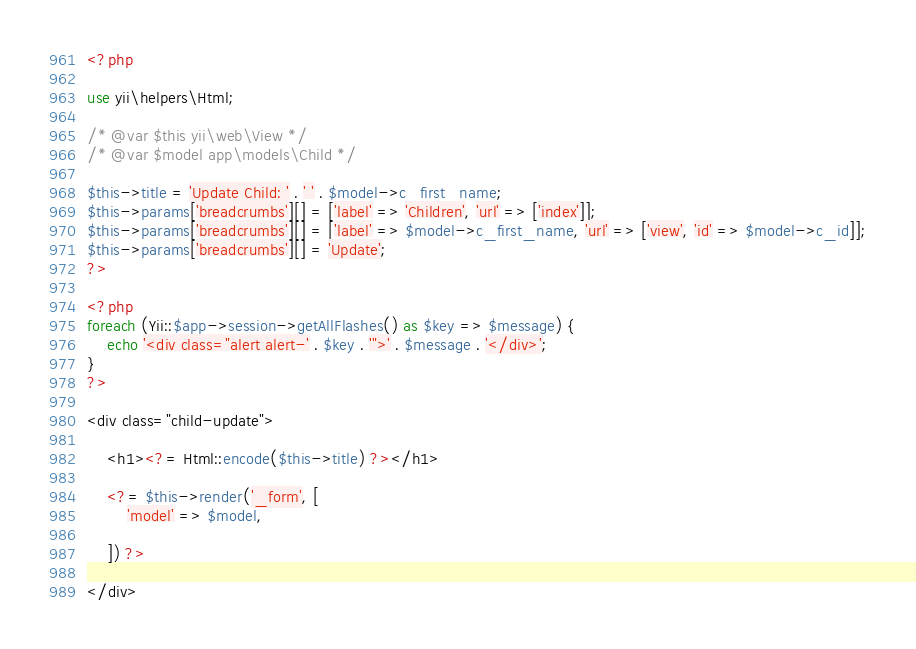Convert code to text. <code><loc_0><loc_0><loc_500><loc_500><_PHP_><?php

use yii\helpers\Html;

/* @var $this yii\web\View */
/* @var $model app\models\Child */

$this->title = 'Update Child: ' . ' ' . $model->c_first_name;
$this->params['breadcrumbs'][] = ['label' => 'Children', 'url' => ['index']];
$this->params['breadcrumbs'][] = ['label' => $model->c_first_name, 'url' => ['view', 'id' => $model->c_id]];
$this->params['breadcrumbs'][] = 'Update';
?>

<?php
foreach (Yii::$app->session->getAllFlashes() as $key => $message) {
    echo '<div class="alert alert-' . $key . '">' . $message . '</div>';
}
?>

<div class="child-update">

    <h1><?= Html::encode($this->title) ?></h1>

    <?= $this->render('_form', [
        'model' => $model,
                    
    ]) ?>

</div>
</code> 